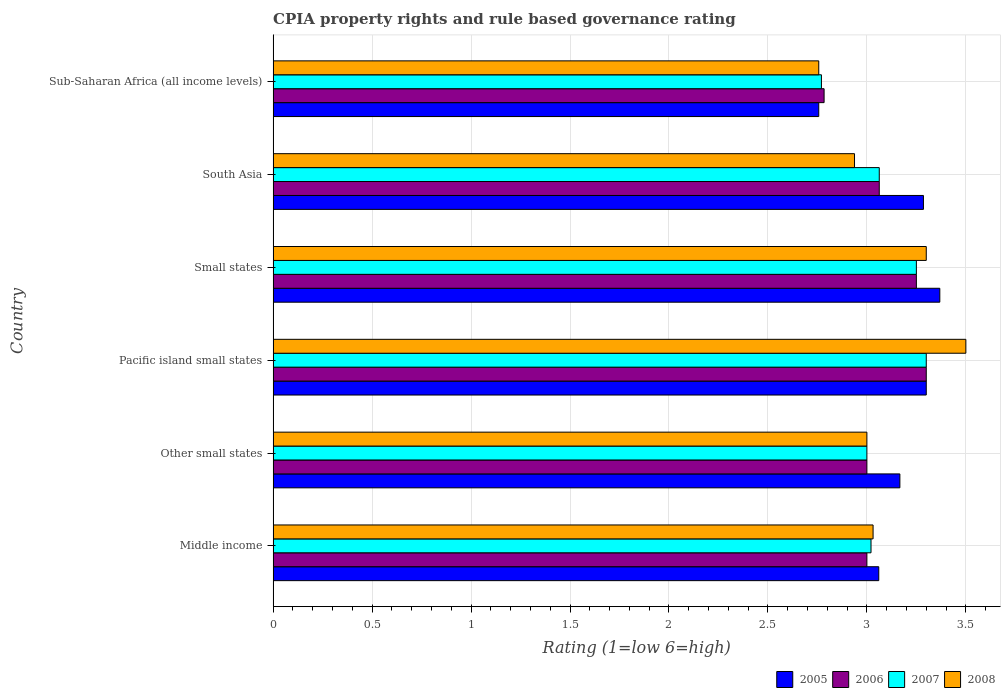How many different coloured bars are there?
Provide a short and direct response. 4. Are the number of bars on each tick of the Y-axis equal?
Keep it short and to the point. Yes. What is the label of the 3rd group of bars from the top?
Your response must be concise. Small states. In how many cases, is the number of bars for a given country not equal to the number of legend labels?
Provide a succinct answer. 0. What is the CPIA rating in 2007 in Sub-Saharan Africa (all income levels)?
Your answer should be very brief. 2.77. Across all countries, what is the maximum CPIA rating in 2005?
Give a very brief answer. 3.37. Across all countries, what is the minimum CPIA rating in 2005?
Your response must be concise. 2.76. In which country was the CPIA rating in 2006 maximum?
Your answer should be compact. Pacific island small states. In which country was the CPIA rating in 2006 minimum?
Your answer should be very brief. Sub-Saharan Africa (all income levels). What is the total CPIA rating in 2005 in the graph?
Give a very brief answer. 18.94. What is the difference between the CPIA rating in 2005 in Middle income and that in Pacific island small states?
Ensure brevity in your answer.  -0.24. What is the difference between the CPIA rating in 2007 in South Asia and the CPIA rating in 2008 in Small states?
Your answer should be very brief. -0.24. What is the average CPIA rating in 2008 per country?
Ensure brevity in your answer.  3.09. What is the difference between the CPIA rating in 2006 and CPIA rating in 2008 in Pacific island small states?
Your answer should be compact. -0.2. In how many countries, is the CPIA rating in 2006 greater than 1.4 ?
Give a very brief answer. 6. What is the ratio of the CPIA rating in 2008 in Small states to that in Sub-Saharan Africa (all income levels)?
Keep it short and to the point. 1.2. Is the CPIA rating in 2006 in Small states less than that in Sub-Saharan Africa (all income levels)?
Provide a succinct answer. No. What is the difference between the highest and the second highest CPIA rating in 2006?
Give a very brief answer. 0.05. What is the difference between the highest and the lowest CPIA rating in 2008?
Your answer should be compact. 0.74. Is the sum of the CPIA rating in 2005 in Pacific island small states and South Asia greater than the maximum CPIA rating in 2008 across all countries?
Give a very brief answer. Yes. What does the 2nd bar from the bottom in Small states represents?
Your answer should be very brief. 2006. How many bars are there?
Make the answer very short. 24. Are the values on the major ticks of X-axis written in scientific E-notation?
Provide a short and direct response. No. Does the graph contain any zero values?
Ensure brevity in your answer.  No. Where does the legend appear in the graph?
Ensure brevity in your answer.  Bottom right. What is the title of the graph?
Your answer should be very brief. CPIA property rights and rule based governance rating. What is the label or title of the X-axis?
Offer a terse response. Rating (1=low 6=high). What is the label or title of the Y-axis?
Provide a succinct answer. Country. What is the Rating (1=low 6=high) of 2005 in Middle income?
Give a very brief answer. 3.06. What is the Rating (1=low 6=high) of 2006 in Middle income?
Your response must be concise. 3. What is the Rating (1=low 6=high) of 2007 in Middle income?
Give a very brief answer. 3.02. What is the Rating (1=low 6=high) in 2008 in Middle income?
Keep it short and to the point. 3.03. What is the Rating (1=low 6=high) in 2005 in Other small states?
Make the answer very short. 3.17. What is the Rating (1=low 6=high) in 2006 in Other small states?
Your answer should be very brief. 3. What is the Rating (1=low 6=high) in 2008 in Other small states?
Offer a terse response. 3. What is the Rating (1=low 6=high) of 2005 in Small states?
Provide a short and direct response. 3.37. What is the Rating (1=low 6=high) in 2005 in South Asia?
Your answer should be compact. 3.29. What is the Rating (1=low 6=high) of 2006 in South Asia?
Ensure brevity in your answer.  3.06. What is the Rating (1=low 6=high) of 2007 in South Asia?
Your answer should be very brief. 3.06. What is the Rating (1=low 6=high) in 2008 in South Asia?
Make the answer very short. 2.94. What is the Rating (1=low 6=high) of 2005 in Sub-Saharan Africa (all income levels)?
Offer a terse response. 2.76. What is the Rating (1=low 6=high) in 2006 in Sub-Saharan Africa (all income levels)?
Give a very brief answer. 2.78. What is the Rating (1=low 6=high) in 2007 in Sub-Saharan Africa (all income levels)?
Your answer should be compact. 2.77. What is the Rating (1=low 6=high) of 2008 in Sub-Saharan Africa (all income levels)?
Give a very brief answer. 2.76. Across all countries, what is the maximum Rating (1=low 6=high) in 2005?
Provide a succinct answer. 3.37. Across all countries, what is the minimum Rating (1=low 6=high) of 2005?
Your answer should be compact. 2.76. Across all countries, what is the minimum Rating (1=low 6=high) in 2006?
Provide a succinct answer. 2.78. Across all countries, what is the minimum Rating (1=low 6=high) of 2007?
Provide a short and direct response. 2.77. Across all countries, what is the minimum Rating (1=low 6=high) of 2008?
Your answer should be compact. 2.76. What is the total Rating (1=low 6=high) of 2005 in the graph?
Keep it short and to the point. 18.94. What is the total Rating (1=low 6=high) in 2006 in the graph?
Ensure brevity in your answer.  18.4. What is the total Rating (1=low 6=high) in 2007 in the graph?
Give a very brief answer. 18.4. What is the total Rating (1=low 6=high) in 2008 in the graph?
Offer a terse response. 18.53. What is the difference between the Rating (1=low 6=high) of 2005 in Middle income and that in Other small states?
Your response must be concise. -0.11. What is the difference between the Rating (1=low 6=high) of 2007 in Middle income and that in Other small states?
Your response must be concise. 0.02. What is the difference between the Rating (1=low 6=high) of 2008 in Middle income and that in Other small states?
Your answer should be compact. 0.03. What is the difference between the Rating (1=low 6=high) in 2005 in Middle income and that in Pacific island small states?
Keep it short and to the point. -0.24. What is the difference between the Rating (1=low 6=high) in 2007 in Middle income and that in Pacific island small states?
Provide a succinct answer. -0.28. What is the difference between the Rating (1=low 6=high) in 2008 in Middle income and that in Pacific island small states?
Provide a succinct answer. -0.47. What is the difference between the Rating (1=low 6=high) of 2005 in Middle income and that in Small states?
Your response must be concise. -0.31. What is the difference between the Rating (1=low 6=high) in 2006 in Middle income and that in Small states?
Your answer should be compact. -0.25. What is the difference between the Rating (1=low 6=high) in 2007 in Middle income and that in Small states?
Give a very brief answer. -0.23. What is the difference between the Rating (1=low 6=high) in 2008 in Middle income and that in Small states?
Give a very brief answer. -0.27. What is the difference between the Rating (1=low 6=high) of 2005 in Middle income and that in South Asia?
Your answer should be very brief. -0.23. What is the difference between the Rating (1=low 6=high) in 2006 in Middle income and that in South Asia?
Make the answer very short. -0.06. What is the difference between the Rating (1=low 6=high) in 2007 in Middle income and that in South Asia?
Provide a short and direct response. -0.04. What is the difference between the Rating (1=low 6=high) of 2008 in Middle income and that in South Asia?
Make the answer very short. 0.09. What is the difference between the Rating (1=low 6=high) of 2005 in Middle income and that in Sub-Saharan Africa (all income levels)?
Offer a very short reply. 0.3. What is the difference between the Rating (1=low 6=high) in 2006 in Middle income and that in Sub-Saharan Africa (all income levels)?
Your response must be concise. 0.22. What is the difference between the Rating (1=low 6=high) of 2007 in Middle income and that in Sub-Saharan Africa (all income levels)?
Your response must be concise. 0.25. What is the difference between the Rating (1=low 6=high) of 2008 in Middle income and that in Sub-Saharan Africa (all income levels)?
Your answer should be compact. 0.27. What is the difference between the Rating (1=low 6=high) in 2005 in Other small states and that in Pacific island small states?
Provide a succinct answer. -0.13. What is the difference between the Rating (1=low 6=high) in 2007 in Other small states and that in Pacific island small states?
Provide a short and direct response. -0.3. What is the difference between the Rating (1=low 6=high) of 2008 in Other small states and that in Pacific island small states?
Ensure brevity in your answer.  -0.5. What is the difference between the Rating (1=low 6=high) of 2005 in Other small states and that in Small states?
Ensure brevity in your answer.  -0.2. What is the difference between the Rating (1=low 6=high) in 2005 in Other small states and that in South Asia?
Make the answer very short. -0.12. What is the difference between the Rating (1=low 6=high) in 2006 in Other small states and that in South Asia?
Your answer should be very brief. -0.06. What is the difference between the Rating (1=low 6=high) in 2007 in Other small states and that in South Asia?
Give a very brief answer. -0.06. What is the difference between the Rating (1=low 6=high) of 2008 in Other small states and that in South Asia?
Provide a succinct answer. 0.06. What is the difference between the Rating (1=low 6=high) in 2005 in Other small states and that in Sub-Saharan Africa (all income levels)?
Your answer should be compact. 0.41. What is the difference between the Rating (1=low 6=high) in 2006 in Other small states and that in Sub-Saharan Africa (all income levels)?
Provide a succinct answer. 0.22. What is the difference between the Rating (1=low 6=high) in 2007 in Other small states and that in Sub-Saharan Africa (all income levels)?
Ensure brevity in your answer.  0.23. What is the difference between the Rating (1=low 6=high) in 2008 in Other small states and that in Sub-Saharan Africa (all income levels)?
Your response must be concise. 0.24. What is the difference between the Rating (1=low 6=high) of 2005 in Pacific island small states and that in Small states?
Ensure brevity in your answer.  -0.07. What is the difference between the Rating (1=low 6=high) of 2006 in Pacific island small states and that in Small states?
Give a very brief answer. 0.05. What is the difference between the Rating (1=low 6=high) in 2005 in Pacific island small states and that in South Asia?
Offer a terse response. 0.01. What is the difference between the Rating (1=low 6=high) in 2006 in Pacific island small states and that in South Asia?
Your response must be concise. 0.24. What is the difference between the Rating (1=low 6=high) of 2007 in Pacific island small states and that in South Asia?
Your answer should be compact. 0.24. What is the difference between the Rating (1=low 6=high) of 2008 in Pacific island small states and that in South Asia?
Your response must be concise. 0.56. What is the difference between the Rating (1=low 6=high) in 2005 in Pacific island small states and that in Sub-Saharan Africa (all income levels)?
Keep it short and to the point. 0.54. What is the difference between the Rating (1=low 6=high) in 2006 in Pacific island small states and that in Sub-Saharan Africa (all income levels)?
Offer a very short reply. 0.52. What is the difference between the Rating (1=low 6=high) in 2007 in Pacific island small states and that in Sub-Saharan Africa (all income levels)?
Offer a terse response. 0.53. What is the difference between the Rating (1=low 6=high) of 2008 in Pacific island small states and that in Sub-Saharan Africa (all income levels)?
Offer a very short reply. 0.74. What is the difference between the Rating (1=low 6=high) in 2005 in Small states and that in South Asia?
Make the answer very short. 0.08. What is the difference between the Rating (1=low 6=high) in 2006 in Small states and that in South Asia?
Keep it short and to the point. 0.19. What is the difference between the Rating (1=low 6=high) of 2007 in Small states and that in South Asia?
Your answer should be compact. 0.19. What is the difference between the Rating (1=low 6=high) of 2008 in Small states and that in South Asia?
Make the answer very short. 0.36. What is the difference between the Rating (1=low 6=high) in 2005 in Small states and that in Sub-Saharan Africa (all income levels)?
Offer a very short reply. 0.61. What is the difference between the Rating (1=low 6=high) of 2006 in Small states and that in Sub-Saharan Africa (all income levels)?
Offer a very short reply. 0.47. What is the difference between the Rating (1=low 6=high) in 2007 in Small states and that in Sub-Saharan Africa (all income levels)?
Keep it short and to the point. 0.48. What is the difference between the Rating (1=low 6=high) in 2008 in Small states and that in Sub-Saharan Africa (all income levels)?
Keep it short and to the point. 0.54. What is the difference between the Rating (1=low 6=high) of 2005 in South Asia and that in Sub-Saharan Africa (all income levels)?
Your answer should be very brief. 0.53. What is the difference between the Rating (1=low 6=high) of 2006 in South Asia and that in Sub-Saharan Africa (all income levels)?
Offer a terse response. 0.28. What is the difference between the Rating (1=low 6=high) in 2007 in South Asia and that in Sub-Saharan Africa (all income levels)?
Your answer should be very brief. 0.29. What is the difference between the Rating (1=low 6=high) in 2008 in South Asia and that in Sub-Saharan Africa (all income levels)?
Offer a very short reply. 0.18. What is the difference between the Rating (1=low 6=high) in 2006 in Middle income and the Rating (1=low 6=high) in 2007 in Other small states?
Make the answer very short. 0. What is the difference between the Rating (1=low 6=high) of 2006 in Middle income and the Rating (1=low 6=high) of 2008 in Other small states?
Your response must be concise. 0. What is the difference between the Rating (1=low 6=high) of 2007 in Middle income and the Rating (1=low 6=high) of 2008 in Other small states?
Offer a very short reply. 0.02. What is the difference between the Rating (1=low 6=high) in 2005 in Middle income and the Rating (1=low 6=high) in 2006 in Pacific island small states?
Your response must be concise. -0.24. What is the difference between the Rating (1=low 6=high) in 2005 in Middle income and the Rating (1=low 6=high) in 2007 in Pacific island small states?
Your answer should be very brief. -0.24. What is the difference between the Rating (1=low 6=high) in 2005 in Middle income and the Rating (1=low 6=high) in 2008 in Pacific island small states?
Give a very brief answer. -0.44. What is the difference between the Rating (1=low 6=high) in 2006 in Middle income and the Rating (1=low 6=high) in 2007 in Pacific island small states?
Provide a short and direct response. -0.3. What is the difference between the Rating (1=low 6=high) of 2006 in Middle income and the Rating (1=low 6=high) of 2008 in Pacific island small states?
Offer a very short reply. -0.5. What is the difference between the Rating (1=low 6=high) of 2007 in Middle income and the Rating (1=low 6=high) of 2008 in Pacific island small states?
Keep it short and to the point. -0.48. What is the difference between the Rating (1=low 6=high) of 2005 in Middle income and the Rating (1=low 6=high) of 2006 in Small states?
Give a very brief answer. -0.19. What is the difference between the Rating (1=low 6=high) of 2005 in Middle income and the Rating (1=low 6=high) of 2007 in Small states?
Keep it short and to the point. -0.19. What is the difference between the Rating (1=low 6=high) of 2005 in Middle income and the Rating (1=low 6=high) of 2008 in Small states?
Offer a terse response. -0.24. What is the difference between the Rating (1=low 6=high) in 2006 in Middle income and the Rating (1=low 6=high) in 2008 in Small states?
Offer a terse response. -0.3. What is the difference between the Rating (1=low 6=high) in 2007 in Middle income and the Rating (1=low 6=high) in 2008 in Small states?
Ensure brevity in your answer.  -0.28. What is the difference between the Rating (1=low 6=high) of 2005 in Middle income and the Rating (1=low 6=high) of 2006 in South Asia?
Give a very brief answer. -0. What is the difference between the Rating (1=low 6=high) in 2005 in Middle income and the Rating (1=low 6=high) in 2007 in South Asia?
Keep it short and to the point. -0. What is the difference between the Rating (1=low 6=high) of 2005 in Middle income and the Rating (1=low 6=high) of 2008 in South Asia?
Your response must be concise. 0.12. What is the difference between the Rating (1=low 6=high) in 2006 in Middle income and the Rating (1=low 6=high) in 2007 in South Asia?
Your answer should be compact. -0.06. What is the difference between the Rating (1=low 6=high) in 2006 in Middle income and the Rating (1=low 6=high) in 2008 in South Asia?
Ensure brevity in your answer.  0.06. What is the difference between the Rating (1=low 6=high) of 2007 in Middle income and the Rating (1=low 6=high) of 2008 in South Asia?
Give a very brief answer. 0.08. What is the difference between the Rating (1=low 6=high) in 2005 in Middle income and the Rating (1=low 6=high) in 2006 in Sub-Saharan Africa (all income levels)?
Provide a succinct answer. 0.28. What is the difference between the Rating (1=low 6=high) in 2005 in Middle income and the Rating (1=low 6=high) in 2007 in Sub-Saharan Africa (all income levels)?
Make the answer very short. 0.29. What is the difference between the Rating (1=low 6=high) in 2005 in Middle income and the Rating (1=low 6=high) in 2008 in Sub-Saharan Africa (all income levels)?
Your answer should be very brief. 0.3. What is the difference between the Rating (1=low 6=high) of 2006 in Middle income and the Rating (1=low 6=high) of 2007 in Sub-Saharan Africa (all income levels)?
Offer a very short reply. 0.23. What is the difference between the Rating (1=low 6=high) in 2006 in Middle income and the Rating (1=low 6=high) in 2008 in Sub-Saharan Africa (all income levels)?
Make the answer very short. 0.24. What is the difference between the Rating (1=low 6=high) of 2007 in Middle income and the Rating (1=low 6=high) of 2008 in Sub-Saharan Africa (all income levels)?
Offer a very short reply. 0.26. What is the difference between the Rating (1=low 6=high) of 2005 in Other small states and the Rating (1=low 6=high) of 2006 in Pacific island small states?
Make the answer very short. -0.13. What is the difference between the Rating (1=low 6=high) in 2005 in Other small states and the Rating (1=low 6=high) in 2007 in Pacific island small states?
Your answer should be very brief. -0.13. What is the difference between the Rating (1=low 6=high) of 2005 in Other small states and the Rating (1=low 6=high) of 2008 in Pacific island small states?
Your answer should be compact. -0.33. What is the difference between the Rating (1=low 6=high) in 2006 in Other small states and the Rating (1=low 6=high) in 2007 in Pacific island small states?
Your answer should be compact. -0.3. What is the difference between the Rating (1=low 6=high) of 2007 in Other small states and the Rating (1=low 6=high) of 2008 in Pacific island small states?
Make the answer very short. -0.5. What is the difference between the Rating (1=low 6=high) in 2005 in Other small states and the Rating (1=low 6=high) in 2006 in Small states?
Keep it short and to the point. -0.08. What is the difference between the Rating (1=low 6=high) of 2005 in Other small states and the Rating (1=low 6=high) of 2007 in Small states?
Make the answer very short. -0.08. What is the difference between the Rating (1=low 6=high) of 2005 in Other small states and the Rating (1=low 6=high) of 2008 in Small states?
Provide a short and direct response. -0.13. What is the difference between the Rating (1=low 6=high) of 2006 in Other small states and the Rating (1=low 6=high) of 2007 in Small states?
Your answer should be compact. -0.25. What is the difference between the Rating (1=low 6=high) in 2007 in Other small states and the Rating (1=low 6=high) in 2008 in Small states?
Your answer should be compact. -0.3. What is the difference between the Rating (1=low 6=high) in 2005 in Other small states and the Rating (1=low 6=high) in 2006 in South Asia?
Provide a short and direct response. 0.1. What is the difference between the Rating (1=low 6=high) in 2005 in Other small states and the Rating (1=low 6=high) in 2007 in South Asia?
Give a very brief answer. 0.1. What is the difference between the Rating (1=low 6=high) of 2005 in Other small states and the Rating (1=low 6=high) of 2008 in South Asia?
Give a very brief answer. 0.23. What is the difference between the Rating (1=low 6=high) in 2006 in Other small states and the Rating (1=low 6=high) in 2007 in South Asia?
Keep it short and to the point. -0.06. What is the difference between the Rating (1=low 6=high) of 2006 in Other small states and the Rating (1=low 6=high) of 2008 in South Asia?
Provide a short and direct response. 0.06. What is the difference between the Rating (1=low 6=high) of 2007 in Other small states and the Rating (1=low 6=high) of 2008 in South Asia?
Offer a very short reply. 0.06. What is the difference between the Rating (1=low 6=high) in 2005 in Other small states and the Rating (1=low 6=high) in 2006 in Sub-Saharan Africa (all income levels)?
Your answer should be very brief. 0.38. What is the difference between the Rating (1=low 6=high) in 2005 in Other small states and the Rating (1=low 6=high) in 2007 in Sub-Saharan Africa (all income levels)?
Offer a terse response. 0.4. What is the difference between the Rating (1=low 6=high) of 2005 in Other small states and the Rating (1=low 6=high) of 2008 in Sub-Saharan Africa (all income levels)?
Provide a short and direct response. 0.41. What is the difference between the Rating (1=low 6=high) of 2006 in Other small states and the Rating (1=low 6=high) of 2007 in Sub-Saharan Africa (all income levels)?
Provide a short and direct response. 0.23. What is the difference between the Rating (1=low 6=high) in 2006 in Other small states and the Rating (1=low 6=high) in 2008 in Sub-Saharan Africa (all income levels)?
Keep it short and to the point. 0.24. What is the difference between the Rating (1=low 6=high) of 2007 in Other small states and the Rating (1=low 6=high) of 2008 in Sub-Saharan Africa (all income levels)?
Your response must be concise. 0.24. What is the difference between the Rating (1=low 6=high) in 2005 in Pacific island small states and the Rating (1=low 6=high) in 2007 in Small states?
Provide a succinct answer. 0.05. What is the difference between the Rating (1=low 6=high) of 2006 in Pacific island small states and the Rating (1=low 6=high) of 2007 in Small states?
Make the answer very short. 0.05. What is the difference between the Rating (1=low 6=high) in 2007 in Pacific island small states and the Rating (1=low 6=high) in 2008 in Small states?
Offer a very short reply. 0. What is the difference between the Rating (1=low 6=high) of 2005 in Pacific island small states and the Rating (1=low 6=high) of 2006 in South Asia?
Offer a terse response. 0.24. What is the difference between the Rating (1=low 6=high) in 2005 in Pacific island small states and the Rating (1=low 6=high) in 2007 in South Asia?
Your answer should be compact. 0.24. What is the difference between the Rating (1=low 6=high) in 2005 in Pacific island small states and the Rating (1=low 6=high) in 2008 in South Asia?
Make the answer very short. 0.36. What is the difference between the Rating (1=low 6=high) of 2006 in Pacific island small states and the Rating (1=low 6=high) of 2007 in South Asia?
Provide a succinct answer. 0.24. What is the difference between the Rating (1=low 6=high) of 2006 in Pacific island small states and the Rating (1=low 6=high) of 2008 in South Asia?
Keep it short and to the point. 0.36. What is the difference between the Rating (1=low 6=high) in 2007 in Pacific island small states and the Rating (1=low 6=high) in 2008 in South Asia?
Provide a short and direct response. 0.36. What is the difference between the Rating (1=low 6=high) in 2005 in Pacific island small states and the Rating (1=low 6=high) in 2006 in Sub-Saharan Africa (all income levels)?
Offer a very short reply. 0.52. What is the difference between the Rating (1=low 6=high) in 2005 in Pacific island small states and the Rating (1=low 6=high) in 2007 in Sub-Saharan Africa (all income levels)?
Offer a very short reply. 0.53. What is the difference between the Rating (1=low 6=high) of 2005 in Pacific island small states and the Rating (1=low 6=high) of 2008 in Sub-Saharan Africa (all income levels)?
Keep it short and to the point. 0.54. What is the difference between the Rating (1=low 6=high) of 2006 in Pacific island small states and the Rating (1=low 6=high) of 2007 in Sub-Saharan Africa (all income levels)?
Your response must be concise. 0.53. What is the difference between the Rating (1=low 6=high) of 2006 in Pacific island small states and the Rating (1=low 6=high) of 2008 in Sub-Saharan Africa (all income levels)?
Your response must be concise. 0.54. What is the difference between the Rating (1=low 6=high) in 2007 in Pacific island small states and the Rating (1=low 6=high) in 2008 in Sub-Saharan Africa (all income levels)?
Your response must be concise. 0.54. What is the difference between the Rating (1=low 6=high) of 2005 in Small states and the Rating (1=low 6=high) of 2006 in South Asia?
Your answer should be very brief. 0.31. What is the difference between the Rating (1=low 6=high) in 2005 in Small states and the Rating (1=low 6=high) in 2007 in South Asia?
Your answer should be compact. 0.31. What is the difference between the Rating (1=low 6=high) in 2005 in Small states and the Rating (1=low 6=high) in 2008 in South Asia?
Provide a short and direct response. 0.43. What is the difference between the Rating (1=low 6=high) of 2006 in Small states and the Rating (1=low 6=high) of 2007 in South Asia?
Offer a very short reply. 0.19. What is the difference between the Rating (1=low 6=high) in 2006 in Small states and the Rating (1=low 6=high) in 2008 in South Asia?
Offer a very short reply. 0.31. What is the difference between the Rating (1=low 6=high) in 2007 in Small states and the Rating (1=low 6=high) in 2008 in South Asia?
Offer a very short reply. 0.31. What is the difference between the Rating (1=low 6=high) of 2005 in Small states and the Rating (1=low 6=high) of 2006 in Sub-Saharan Africa (all income levels)?
Provide a succinct answer. 0.58. What is the difference between the Rating (1=low 6=high) of 2005 in Small states and the Rating (1=low 6=high) of 2007 in Sub-Saharan Africa (all income levels)?
Make the answer very short. 0.6. What is the difference between the Rating (1=low 6=high) in 2005 in Small states and the Rating (1=low 6=high) in 2008 in Sub-Saharan Africa (all income levels)?
Give a very brief answer. 0.61. What is the difference between the Rating (1=low 6=high) in 2006 in Small states and the Rating (1=low 6=high) in 2007 in Sub-Saharan Africa (all income levels)?
Make the answer very short. 0.48. What is the difference between the Rating (1=low 6=high) of 2006 in Small states and the Rating (1=low 6=high) of 2008 in Sub-Saharan Africa (all income levels)?
Ensure brevity in your answer.  0.49. What is the difference between the Rating (1=low 6=high) of 2007 in Small states and the Rating (1=low 6=high) of 2008 in Sub-Saharan Africa (all income levels)?
Offer a very short reply. 0.49. What is the difference between the Rating (1=low 6=high) in 2005 in South Asia and the Rating (1=low 6=high) in 2006 in Sub-Saharan Africa (all income levels)?
Give a very brief answer. 0.5. What is the difference between the Rating (1=low 6=high) in 2005 in South Asia and the Rating (1=low 6=high) in 2007 in Sub-Saharan Africa (all income levels)?
Your response must be concise. 0.52. What is the difference between the Rating (1=low 6=high) in 2005 in South Asia and the Rating (1=low 6=high) in 2008 in Sub-Saharan Africa (all income levels)?
Offer a terse response. 0.53. What is the difference between the Rating (1=low 6=high) of 2006 in South Asia and the Rating (1=low 6=high) of 2007 in Sub-Saharan Africa (all income levels)?
Provide a succinct answer. 0.29. What is the difference between the Rating (1=low 6=high) of 2006 in South Asia and the Rating (1=low 6=high) of 2008 in Sub-Saharan Africa (all income levels)?
Offer a very short reply. 0.31. What is the difference between the Rating (1=low 6=high) of 2007 in South Asia and the Rating (1=low 6=high) of 2008 in Sub-Saharan Africa (all income levels)?
Keep it short and to the point. 0.31. What is the average Rating (1=low 6=high) of 2005 per country?
Give a very brief answer. 3.16. What is the average Rating (1=low 6=high) of 2006 per country?
Ensure brevity in your answer.  3.07. What is the average Rating (1=low 6=high) of 2007 per country?
Give a very brief answer. 3.07. What is the average Rating (1=low 6=high) of 2008 per country?
Offer a terse response. 3.09. What is the difference between the Rating (1=low 6=high) of 2005 and Rating (1=low 6=high) of 2007 in Middle income?
Offer a terse response. 0.04. What is the difference between the Rating (1=low 6=high) of 2005 and Rating (1=low 6=high) of 2008 in Middle income?
Keep it short and to the point. 0.03. What is the difference between the Rating (1=low 6=high) in 2006 and Rating (1=low 6=high) in 2007 in Middle income?
Give a very brief answer. -0.02. What is the difference between the Rating (1=low 6=high) of 2006 and Rating (1=low 6=high) of 2008 in Middle income?
Your answer should be compact. -0.03. What is the difference between the Rating (1=low 6=high) of 2007 and Rating (1=low 6=high) of 2008 in Middle income?
Make the answer very short. -0.01. What is the difference between the Rating (1=low 6=high) in 2005 and Rating (1=low 6=high) in 2006 in Other small states?
Provide a succinct answer. 0.17. What is the difference between the Rating (1=low 6=high) of 2005 and Rating (1=low 6=high) of 2008 in Other small states?
Your answer should be very brief. 0.17. What is the difference between the Rating (1=low 6=high) of 2006 and Rating (1=low 6=high) of 2007 in Other small states?
Offer a terse response. 0. What is the difference between the Rating (1=low 6=high) in 2006 and Rating (1=low 6=high) in 2008 in Pacific island small states?
Provide a succinct answer. -0.2. What is the difference between the Rating (1=low 6=high) of 2005 and Rating (1=low 6=high) of 2006 in Small states?
Your answer should be very brief. 0.12. What is the difference between the Rating (1=low 6=high) in 2005 and Rating (1=low 6=high) in 2007 in Small states?
Ensure brevity in your answer.  0.12. What is the difference between the Rating (1=low 6=high) of 2005 and Rating (1=low 6=high) of 2008 in Small states?
Ensure brevity in your answer.  0.07. What is the difference between the Rating (1=low 6=high) in 2005 and Rating (1=low 6=high) in 2006 in South Asia?
Ensure brevity in your answer.  0.22. What is the difference between the Rating (1=low 6=high) of 2005 and Rating (1=low 6=high) of 2007 in South Asia?
Offer a terse response. 0.22. What is the difference between the Rating (1=low 6=high) in 2005 and Rating (1=low 6=high) in 2008 in South Asia?
Keep it short and to the point. 0.35. What is the difference between the Rating (1=low 6=high) of 2006 and Rating (1=low 6=high) of 2008 in South Asia?
Provide a succinct answer. 0.12. What is the difference between the Rating (1=low 6=high) in 2005 and Rating (1=low 6=high) in 2006 in Sub-Saharan Africa (all income levels)?
Provide a short and direct response. -0.03. What is the difference between the Rating (1=low 6=high) of 2005 and Rating (1=low 6=high) of 2007 in Sub-Saharan Africa (all income levels)?
Offer a very short reply. -0.01. What is the difference between the Rating (1=low 6=high) of 2005 and Rating (1=low 6=high) of 2008 in Sub-Saharan Africa (all income levels)?
Your answer should be compact. 0. What is the difference between the Rating (1=low 6=high) of 2006 and Rating (1=low 6=high) of 2007 in Sub-Saharan Africa (all income levels)?
Offer a terse response. 0.01. What is the difference between the Rating (1=low 6=high) in 2006 and Rating (1=low 6=high) in 2008 in Sub-Saharan Africa (all income levels)?
Make the answer very short. 0.03. What is the difference between the Rating (1=low 6=high) of 2007 and Rating (1=low 6=high) of 2008 in Sub-Saharan Africa (all income levels)?
Ensure brevity in your answer.  0.01. What is the ratio of the Rating (1=low 6=high) in 2005 in Middle income to that in Other small states?
Provide a succinct answer. 0.97. What is the ratio of the Rating (1=low 6=high) of 2008 in Middle income to that in Other small states?
Your answer should be compact. 1.01. What is the ratio of the Rating (1=low 6=high) in 2005 in Middle income to that in Pacific island small states?
Make the answer very short. 0.93. What is the ratio of the Rating (1=low 6=high) of 2007 in Middle income to that in Pacific island small states?
Offer a very short reply. 0.92. What is the ratio of the Rating (1=low 6=high) of 2008 in Middle income to that in Pacific island small states?
Offer a very short reply. 0.87. What is the ratio of the Rating (1=low 6=high) of 2005 in Middle income to that in Small states?
Offer a terse response. 0.91. What is the ratio of the Rating (1=low 6=high) in 2007 in Middle income to that in Small states?
Keep it short and to the point. 0.93. What is the ratio of the Rating (1=low 6=high) in 2008 in Middle income to that in Small states?
Offer a very short reply. 0.92. What is the ratio of the Rating (1=low 6=high) of 2005 in Middle income to that in South Asia?
Make the answer very short. 0.93. What is the ratio of the Rating (1=low 6=high) of 2006 in Middle income to that in South Asia?
Make the answer very short. 0.98. What is the ratio of the Rating (1=low 6=high) of 2007 in Middle income to that in South Asia?
Your answer should be compact. 0.99. What is the ratio of the Rating (1=low 6=high) in 2008 in Middle income to that in South Asia?
Make the answer very short. 1.03. What is the ratio of the Rating (1=low 6=high) in 2005 in Middle income to that in Sub-Saharan Africa (all income levels)?
Keep it short and to the point. 1.11. What is the ratio of the Rating (1=low 6=high) in 2006 in Middle income to that in Sub-Saharan Africa (all income levels)?
Offer a very short reply. 1.08. What is the ratio of the Rating (1=low 6=high) of 2007 in Middle income to that in Sub-Saharan Africa (all income levels)?
Offer a very short reply. 1.09. What is the ratio of the Rating (1=low 6=high) in 2008 in Middle income to that in Sub-Saharan Africa (all income levels)?
Your answer should be compact. 1.1. What is the ratio of the Rating (1=low 6=high) in 2005 in Other small states to that in Pacific island small states?
Your response must be concise. 0.96. What is the ratio of the Rating (1=low 6=high) in 2006 in Other small states to that in Pacific island small states?
Offer a terse response. 0.91. What is the ratio of the Rating (1=low 6=high) in 2008 in Other small states to that in Pacific island small states?
Offer a very short reply. 0.86. What is the ratio of the Rating (1=low 6=high) in 2005 in Other small states to that in Small states?
Provide a succinct answer. 0.94. What is the ratio of the Rating (1=low 6=high) of 2007 in Other small states to that in Small states?
Your answer should be very brief. 0.92. What is the ratio of the Rating (1=low 6=high) in 2008 in Other small states to that in Small states?
Your answer should be compact. 0.91. What is the ratio of the Rating (1=low 6=high) of 2005 in Other small states to that in South Asia?
Your answer should be very brief. 0.96. What is the ratio of the Rating (1=low 6=high) of 2006 in Other small states to that in South Asia?
Offer a very short reply. 0.98. What is the ratio of the Rating (1=low 6=high) in 2007 in Other small states to that in South Asia?
Ensure brevity in your answer.  0.98. What is the ratio of the Rating (1=low 6=high) in 2008 in Other small states to that in South Asia?
Keep it short and to the point. 1.02. What is the ratio of the Rating (1=low 6=high) in 2005 in Other small states to that in Sub-Saharan Africa (all income levels)?
Keep it short and to the point. 1.15. What is the ratio of the Rating (1=low 6=high) of 2006 in Other small states to that in Sub-Saharan Africa (all income levels)?
Offer a terse response. 1.08. What is the ratio of the Rating (1=low 6=high) of 2007 in Other small states to that in Sub-Saharan Africa (all income levels)?
Offer a terse response. 1.08. What is the ratio of the Rating (1=low 6=high) of 2008 in Other small states to that in Sub-Saharan Africa (all income levels)?
Offer a terse response. 1.09. What is the ratio of the Rating (1=low 6=high) in 2005 in Pacific island small states to that in Small states?
Offer a terse response. 0.98. What is the ratio of the Rating (1=low 6=high) in 2006 in Pacific island small states to that in Small states?
Keep it short and to the point. 1.02. What is the ratio of the Rating (1=low 6=high) of 2007 in Pacific island small states to that in Small states?
Ensure brevity in your answer.  1.02. What is the ratio of the Rating (1=low 6=high) in 2008 in Pacific island small states to that in Small states?
Ensure brevity in your answer.  1.06. What is the ratio of the Rating (1=low 6=high) of 2006 in Pacific island small states to that in South Asia?
Give a very brief answer. 1.08. What is the ratio of the Rating (1=low 6=high) of 2007 in Pacific island small states to that in South Asia?
Provide a short and direct response. 1.08. What is the ratio of the Rating (1=low 6=high) of 2008 in Pacific island small states to that in South Asia?
Give a very brief answer. 1.19. What is the ratio of the Rating (1=low 6=high) of 2005 in Pacific island small states to that in Sub-Saharan Africa (all income levels)?
Make the answer very short. 1.2. What is the ratio of the Rating (1=low 6=high) of 2006 in Pacific island small states to that in Sub-Saharan Africa (all income levels)?
Provide a succinct answer. 1.19. What is the ratio of the Rating (1=low 6=high) of 2007 in Pacific island small states to that in Sub-Saharan Africa (all income levels)?
Your answer should be very brief. 1.19. What is the ratio of the Rating (1=low 6=high) of 2008 in Pacific island small states to that in Sub-Saharan Africa (all income levels)?
Your answer should be compact. 1.27. What is the ratio of the Rating (1=low 6=high) of 2005 in Small states to that in South Asia?
Offer a very short reply. 1.03. What is the ratio of the Rating (1=low 6=high) in 2006 in Small states to that in South Asia?
Ensure brevity in your answer.  1.06. What is the ratio of the Rating (1=low 6=high) in 2007 in Small states to that in South Asia?
Ensure brevity in your answer.  1.06. What is the ratio of the Rating (1=low 6=high) of 2008 in Small states to that in South Asia?
Offer a very short reply. 1.12. What is the ratio of the Rating (1=low 6=high) in 2005 in Small states to that in Sub-Saharan Africa (all income levels)?
Your answer should be compact. 1.22. What is the ratio of the Rating (1=low 6=high) of 2006 in Small states to that in Sub-Saharan Africa (all income levels)?
Ensure brevity in your answer.  1.17. What is the ratio of the Rating (1=low 6=high) of 2007 in Small states to that in Sub-Saharan Africa (all income levels)?
Offer a terse response. 1.17. What is the ratio of the Rating (1=low 6=high) of 2008 in Small states to that in Sub-Saharan Africa (all income levels)?
Offer a terse response. 1.2. What is the ratio of the Rating (1=low 6=high) of 2005 in South Asia to that in Sub-Saharan Africa (all income levels)?
Make the answer very short. 1.19. What is the ratio of the Rating (1=low 6=high) in 2006 in South Asia to that in Sub-Saharan Africa (all income levels)?
Make the answer very short. 1.1. What is the ratio of the Rating (1=low 6=high) of 2007 in South Asia to that in Sub-Saharan Africa (all income levels)?
Your answer should be very brief. 1.11. What is the ratio of the Rating (1=low 6=high) of 2008 in South Asia to that in Sub-Saharan Africa (all income levels)?
Give a very brief answer. 1.07. What is the difference between the highest and the second highest Rating (1=low 6=high) in 2005?
Ensure brevity in your answer.  0.07. What is the difference between the highest and the lowest Rating (1=low 6=high) in 2005?
Offer a terse response. 0.61. What is the difference between the highest and the lowest Rating (1=low 6=high) of 2006?
Give a very brief answer. 0.52. What is the difference between the highest and the lowest Rating (1=low 6=high) in 2007?
Make the answer very short. 0.53. What is the difference between the highest and the lowest Rating (1=low 6=high) in 2008?
Offer a very short reply. 0.74. 